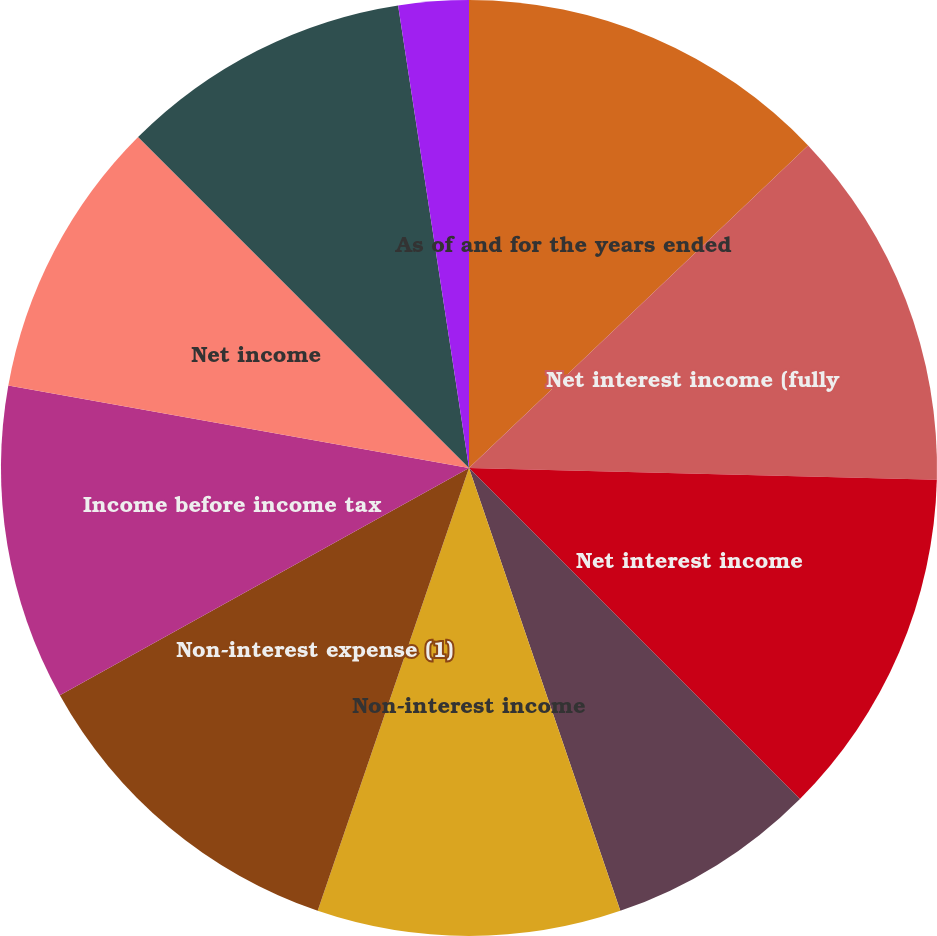Convert chart to OTSL. <chart><loc_0><loc_0><loc_500><loc_500><pie_chart><fcel>As of and for the years ended<fcel>Net interest income (fully<fcel>Net interest income<fcel>Provision for loan losses<fcel>Non-interest income<fcel>Non-interest expense (1)<fcel>Income before income tax<fcel>Net income<fcel>Net income available to common<fcel>Net interest margin<nl><fcel>12.9%<fcel>12.5%<fcel>12.1%<fcel>7.26%<fcel>10.48%<fcel>11.69%<fcel>10.89%<fcel>9.68%<fcel>10.08%<fcel>2.42%<nl></chart> 